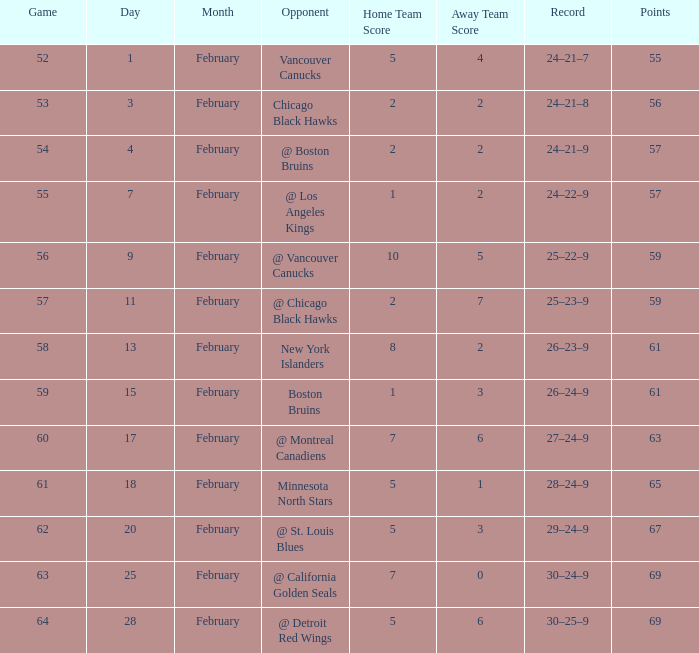Which opponent has a game larger than 61, february smaller than 28, and fewer points than 69? @ St. Louis Blues. 